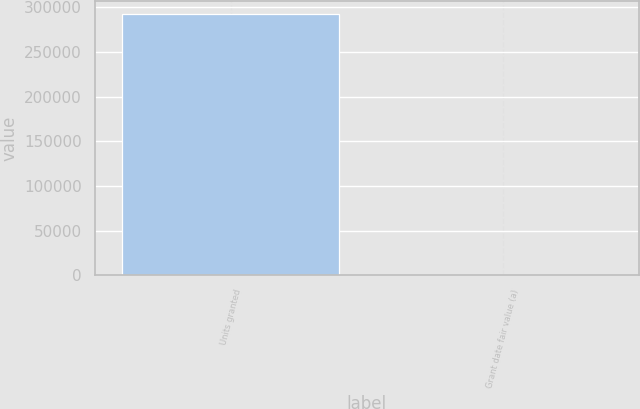<chart> <loc_0><loc_0><loc_500><loc_500><bar_chart><fcel>Units granted<fcel>Grant date fair value (a)<nl><fcel>292242<fcel>41.98<nl></chart> 